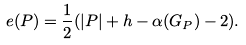Convert formula to latex. <formula><loc_0><loc_0><loc_500><loc_500>e ( P ) = \frac { 1 } { 2 } ( | P | + h - \alpha ( G _ { P } ) - 2 ) .</formula> 